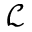Convert formula to latex. <formula><loc_0><loc_0><loc_500><loc_500>\mathcal { L }</formula> 